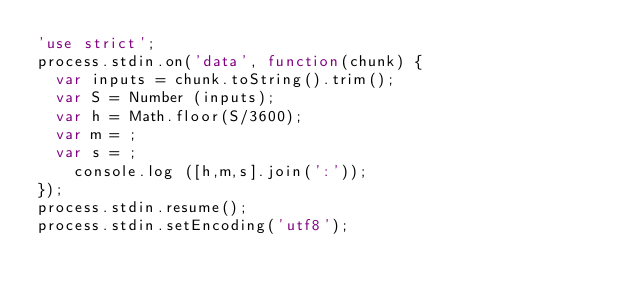Convert code to text. <code><loc_0><loc_0><loc_500><loc_500><_JavaScript_>'use strict';
process.stdin.on('data', function(chunk) {
  var inputs = chunk.toString().trim();
  var S = Number (inputs);
  var h = Math.floor(S/3600);
  var m = ;
  var s = ;
	console.log ([h,m,s].join(':'));
});
process.stdin.resume();
process.stdin.setEncoding('utf8');</code> 